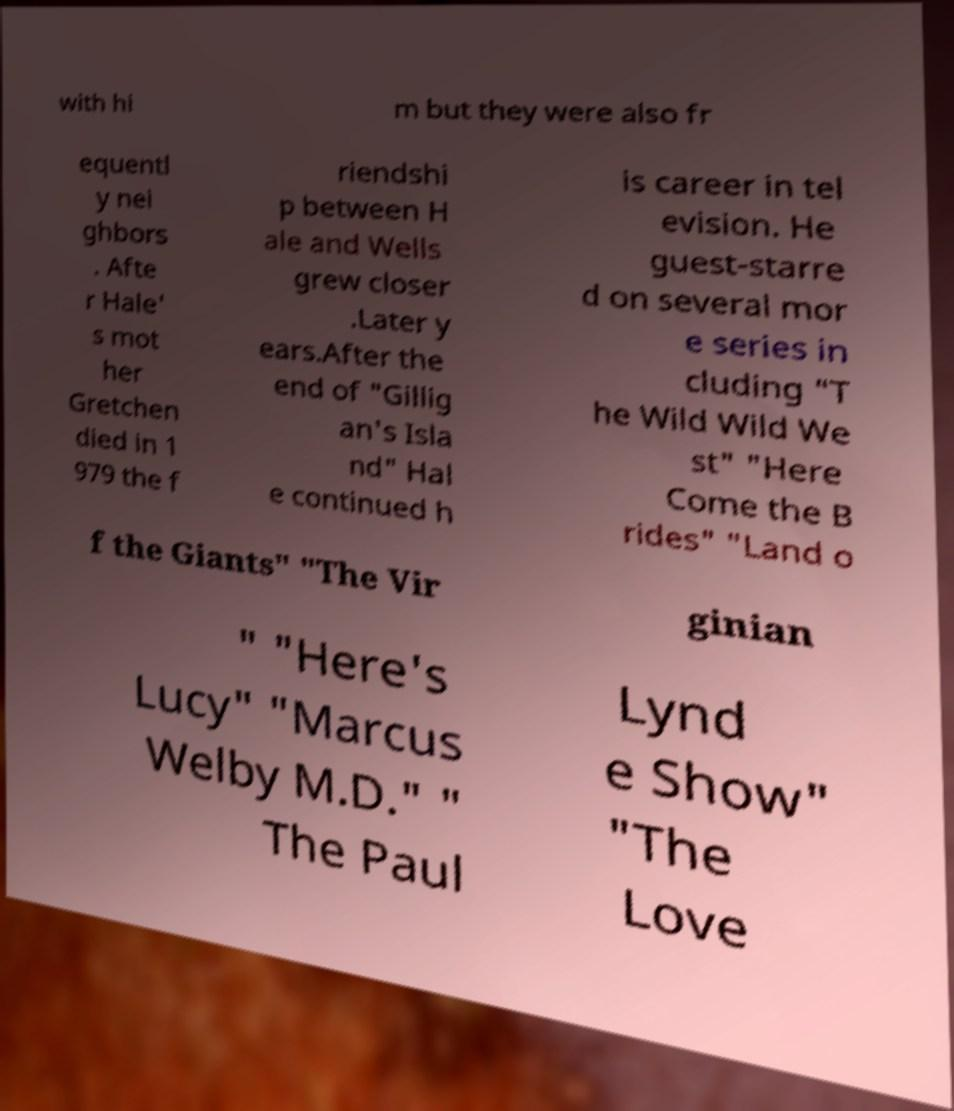Please read and relay the text visible in this image. What does it say? with hi m but they were also fr equentl y nei ghbors . Afte r Hale' s mot her Gretchen died in 1 979 the f riendshi p between H ale and Wells grew closer .Later y ears.After the end of "Gillig an's Isla nd" Hal e continued h is career in tel evision. He guest-starre d on several mor e series in cluding "T he Wild Wild We st" "Here Come the B rides" "Land o f the Giants" "The Vir ginian " "Here's Lucy" "Marcus Welby M.D." " The Paul Lynd e Show" "The Love 